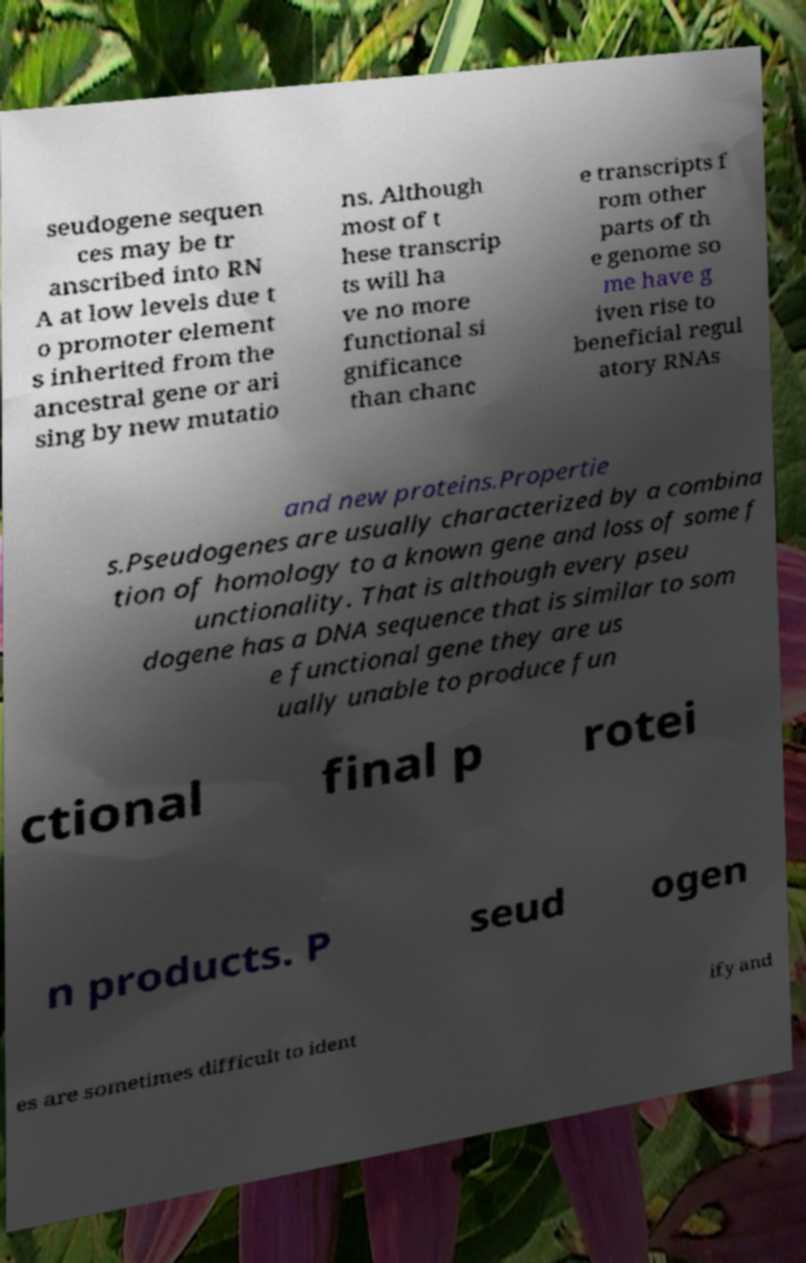I need the written content from this picture converted into text. Can you do that? seudogene sequen ces may be tr anscribed into RN A at low levels due t o promoter element s inherited from the ancestral gene or ari sing by new mutatio ns. Although most of t hese transcrip ts will ha ve no more functional si gnificance than chanc e transcripts f rom other parts of th e genome so me have g iven rise to beneficial regul atory RNAs and new proteins.Propertie s.Pseudogenes are usually characterized by a combina tion of homology to a known gene and loss of some f unctionality. That is although every pseu dogene has a DNA sequence that is similar to som e functional gene they are us ually unable to produce fun ctional final p rotei n products. P seud ogen es are sometimes difficult to ident ify and 